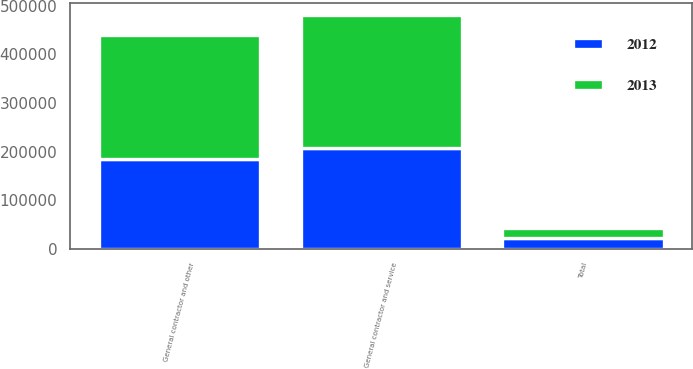<chart> <loc_0><loc_0><loc_500><loc_500><stacked_bar_chart><ecel><fcel>General contractor and service<fcel>General contractor and other<fcel>Total<nl><fcel>2012<fcel>206596<fcel>183833<fcel>22763<nl><fcel>2013<fcel>275071<fcel>254870<fcel>20201<nl></chart> 